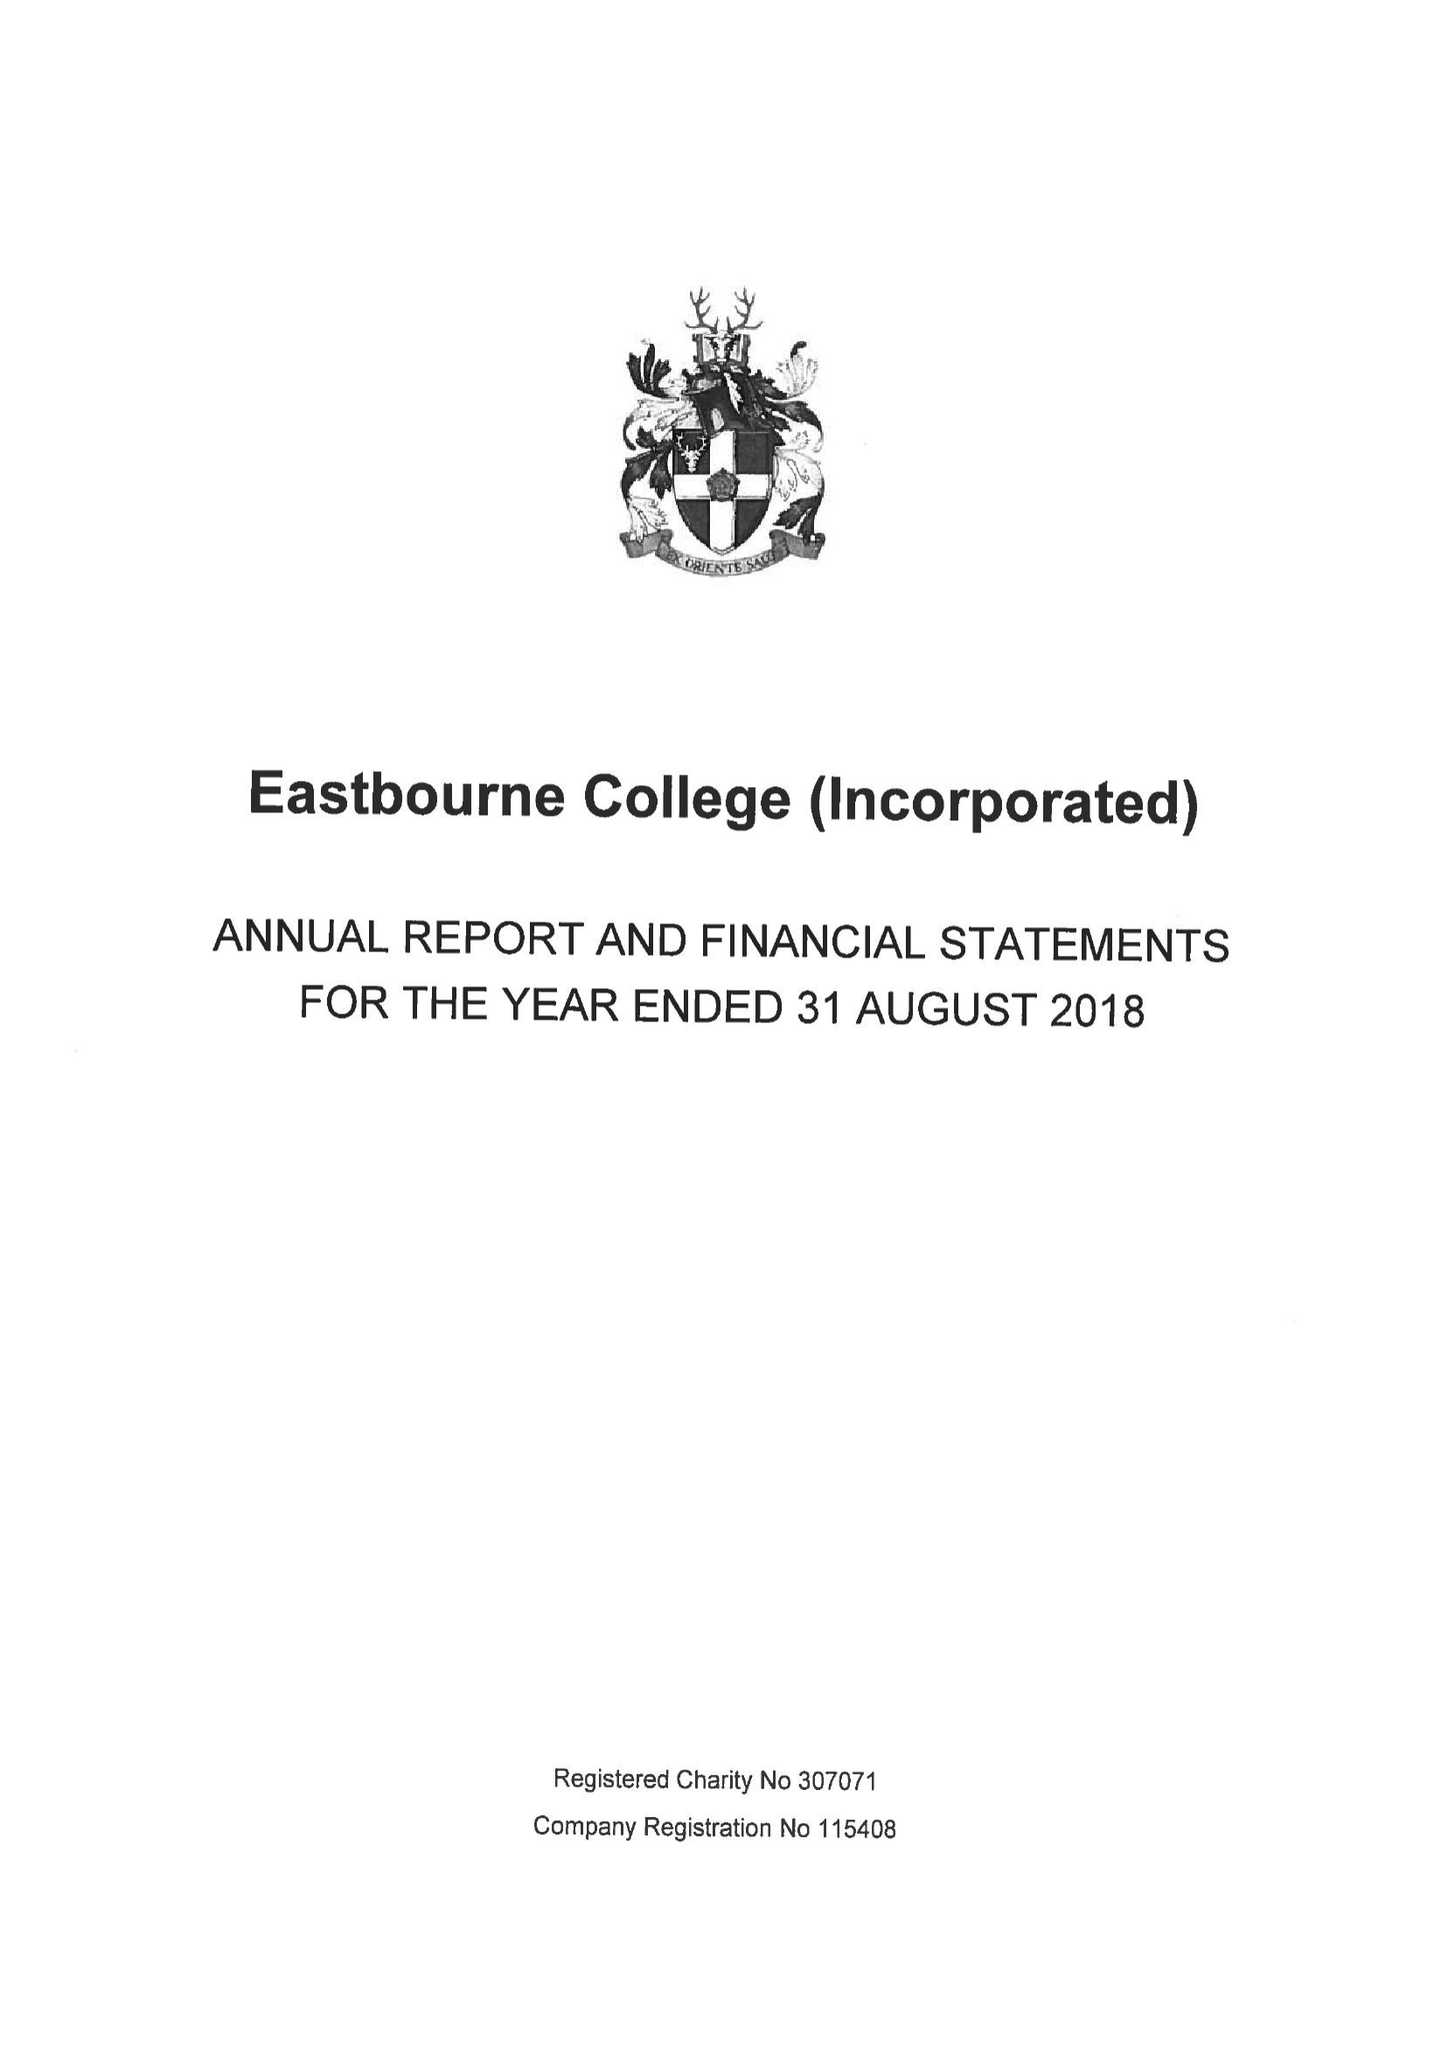What is the value for the report_date?
Answer the question using a single word or phrase. 2018-08-31 